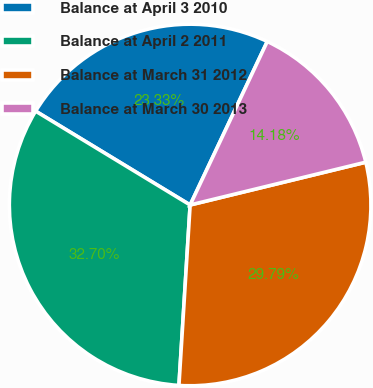<chart> <loc_0><loc_0><loc_500><loc_500><pie_chart><fcel>Balance at April 3 2010<fcel>Balance at April 2 2011<fcel>Balance at March 31 2012<fcel>Balance at March 30 2013<nl><fcel>23.33%<fcel>32.7%<fcel>29.79%<fcel>14.18%<nl></chart> 